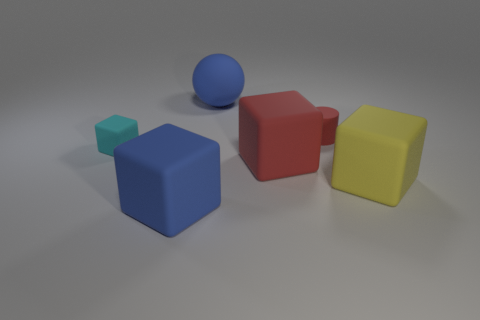Is there any other thing that is the same size as the cyan cube?
Offer a terse response. Yes. Is there a rubber block that has the same color as the small matte cylinder?
Offer a very short reply. Yes. What is the size of the object that is the same color as the sphere?
Your answer should be very brief. Large. How many yellow objects are small metal things or small matte cubes?
Your response must be concise. 0. There is a large rubber thing that is the same color as the large rubber sphere; what is its shape?
Keep it short and to the point. Cube. There is a large rubber object right of the small red cylinder; is its shape the same as the big blue thing that is in front of the cyan matte thing?
Offer a terse response. Yes. What number of blue matte objects are there?
Provide a short and direct response. 2. There is a small cyan thing that is the same material as the big yellow thing; what shape is it?
Offer a terse response. Cube. Are there any other things that are the same color as the large ball?
Give a very brief answer. Yes. There is a matte cylinder; is its color the same as the big block behind the big yellow thing?
Ensure brevity in your answer.  Yes. 